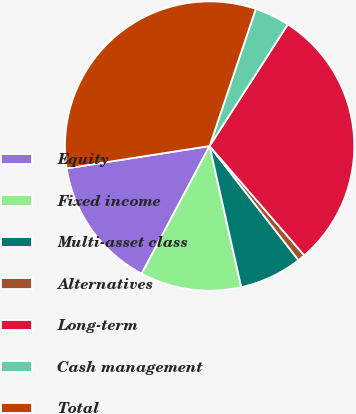Convert chart to OTSL. <chart><loc_0><loc_0><loc_500><loc_500><pie_chart><fcel>Equity<fcel>Fixed income<fcel>Multi-asset class<fcel>Alternatives<fcel>Long-term<fcel>Cash management<fcel>Total<nl><fcel>14.75%<fcel>11.29%<fcel>7.02%<fcel>0.83%<fcel>29.55%<fcel>3.92%<fcel>32.64%<nl></chart> 